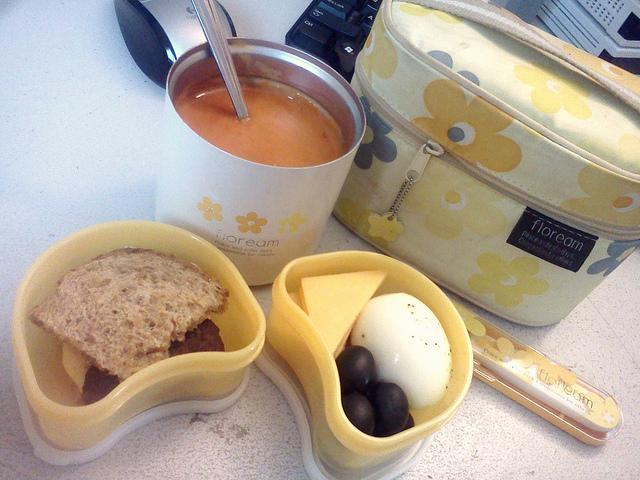What does the item in the can with the utensil look like? soup 